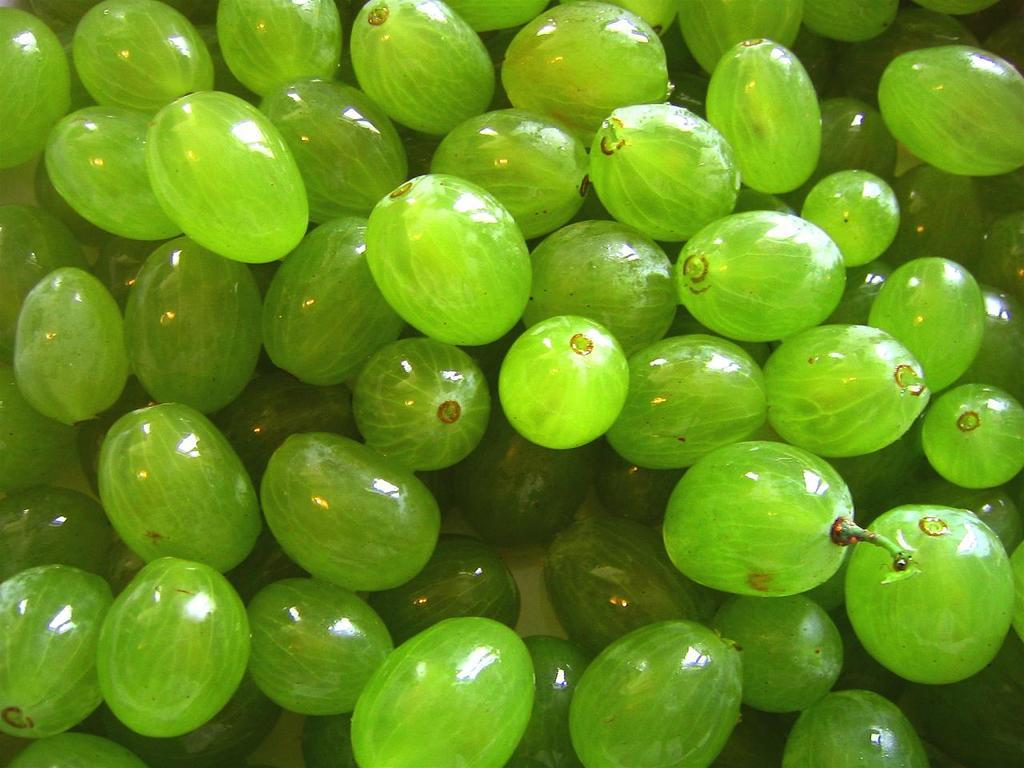What type of fruit is visible in the image? There are green color grapes in the image. How are the grapes arranged in the image? The grapes are arranged on a surface. What color is the background of the image? The background of the image is white. What type of peace can be seen in the image? There is no reference to peace in the image; it features green color grapes arranged on a surface with a white background. 